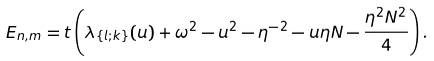<formula> <loc_0><loc_0><loc_500><loc_500>E _ { n , m } = t \left ( \lambda _ { \{ l ; k \} } ( u ) + \omega ^ { 2 } - u ^ { 2 } - \eta ^ { - 2 } - u \eta N - \frac { \eta ^ { 2 } N ^ { 2 } } { 4 } \right ) .</formula> 